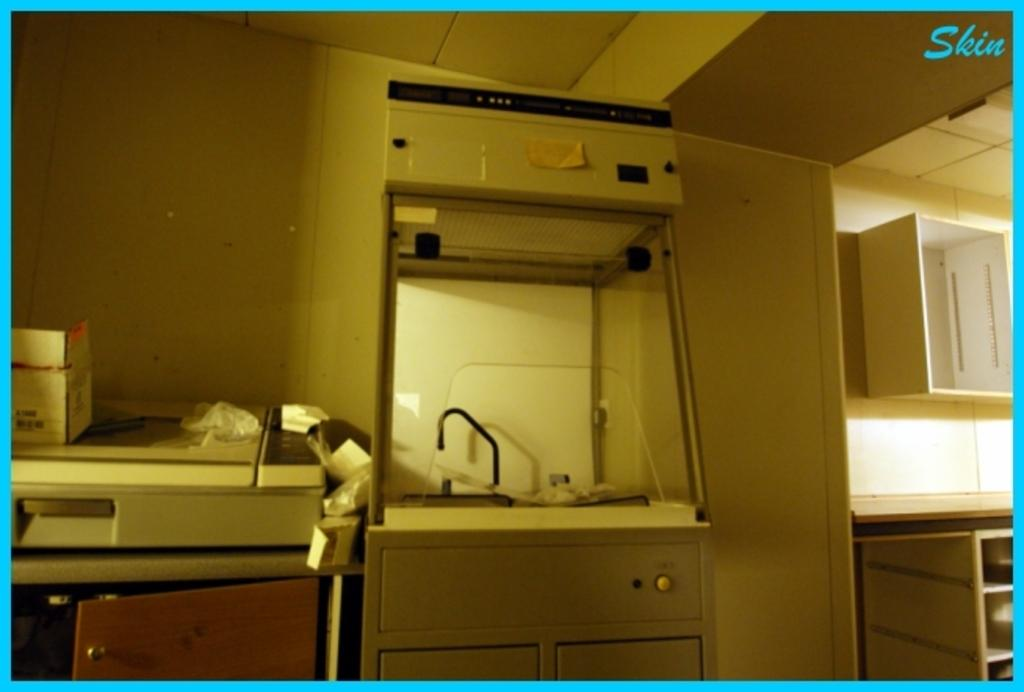What can be observed about the image's appearance? The image appears to be edited. What type of furniture is attached to the walls in the image? There are cupboards and racks attached to the walls in the image. Can you describe any other objects present in the image? There are other objects in the image, but their specific details are not mentioned in the provided facts. What is present in the top right corner of the image? There is a watermark in the top right corner of the image. What type of crown is placed on the brain in the image? There is no brain or crown present in the image; the facts provided do not mention these items. 